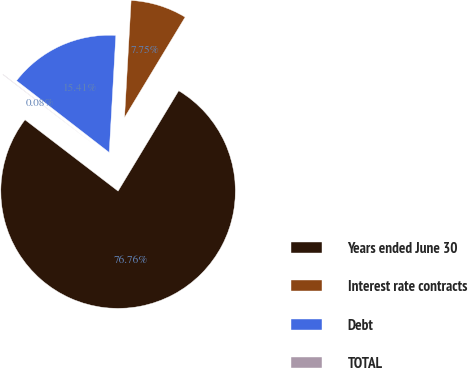Convert chart to OTSL. <chart><loc_0><loc_0><loc_500><loc_500><pie_chart><fcel>Years ended June 30<fcel>Interest rate contracts<fcel>Debt<fcel>TOTAL<nl><fcel>76.76%<fcel>7.75%<fcel>15.41%<fcel>0.08%<nl></chart> 